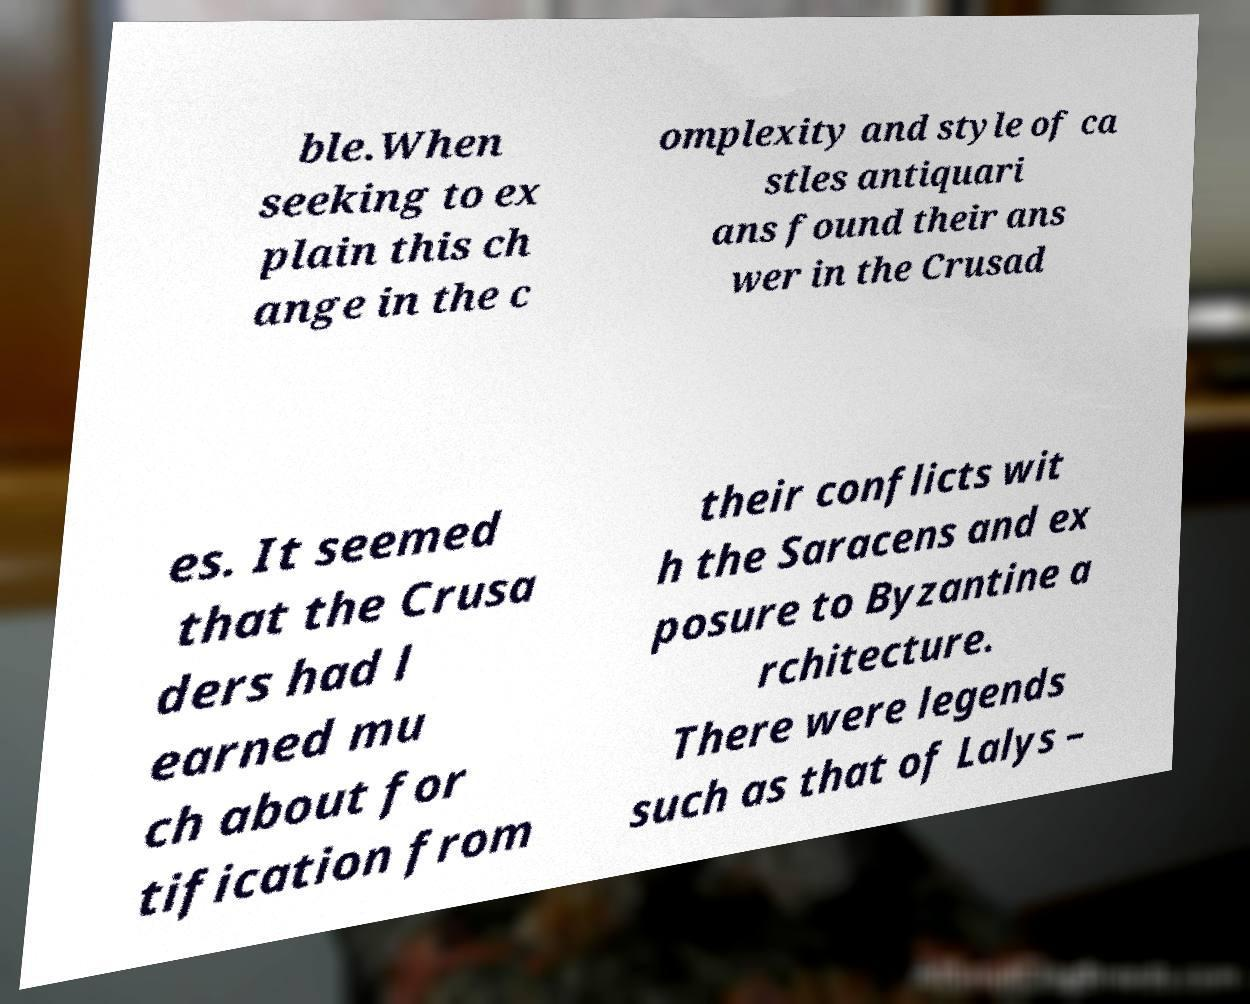Please read and relay the text visible in this image. What does it say? ble.When seeking to ex plain this ch ange in the c omplexity and style of ca stles antiquari ans found their ans wer in the Crusad es. It seemed that the Crusa ders had l earned mu ch about for tification from their conflicts wit h the Saracens and ex posure to Byzantine a rchitecture. There were legends such as that of Lalys – 